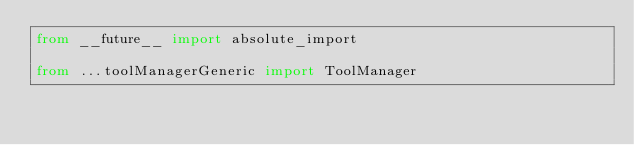Convert code to text. <code><loc_0><loc_0><loc_500><loc_500><_Python_>from __future__ import absolute_import

from ...toolManagerGeneric import ToolManager</code> 